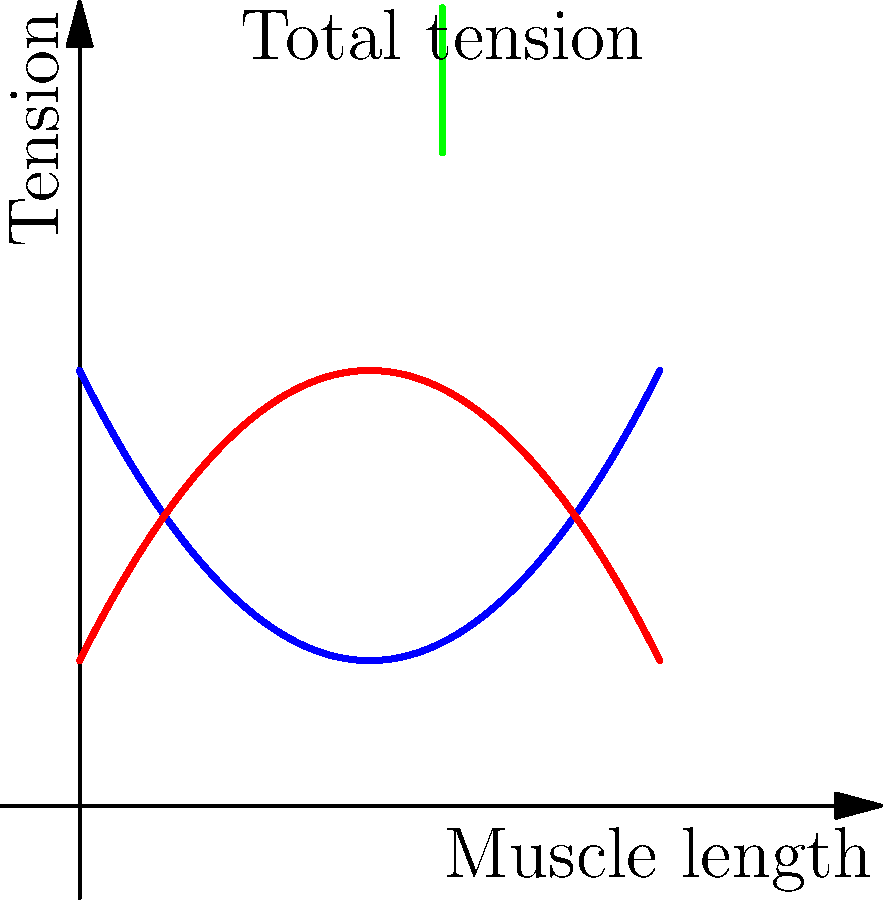As a department leader who values accountability and transparency, you're reviewing a biomechanics report on muscle function. The graph shows the relationship between muscle length and tension during contraction. At which point on the x-axis (muscle length) does the total tension in the muscle reach its maximum? To determine the point of maximum total tension, we need to follow these steps:

1. Understand the graph components:
   - Blue curve: Active tension (tension generated by muscle contraction)
   - Red curve: Passive tension (tension from stretching of connective tissues)
   - Green line: Total tension (sum of active and passive tensions)

2. Observe that the total tension is represented by the vertical distance between the active and passive tension curves.

3. Identify where this vertical distance is greatest:
   - At the left of the graph, the distance is small.
   - As we move right, the distance increases.
   - The distance reaches its maximum around the middle of the graph.
   - Beyond this point, the distance starts to decrease.

4. Estimate the x-coordinate (muscle length) where the total tension is at its maximum:
   - This occurs approximately at the midpoint of the x-axis.
   - Given that the x-axis seems to range from 0 to 4, the midpoint would be at x = 2.

5. Verify that this point aligns with the peak of the imaginary curve that would represent the sum of active and passive tensions.

Therefore, the total tension reaches its maximum when the muscle length is approximately 2 units on the given scale.
Answer: 2 (muscle length units) 